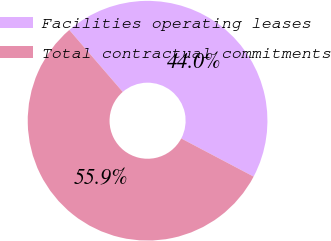<chart> <loc_0><loc_0><loc_500><loc_500><pie_chart><fcel>Facilities operating leases<fcel>Total contractual commitments<nl><fcel>44.05%<fcel>55.95%<nl></chart> 